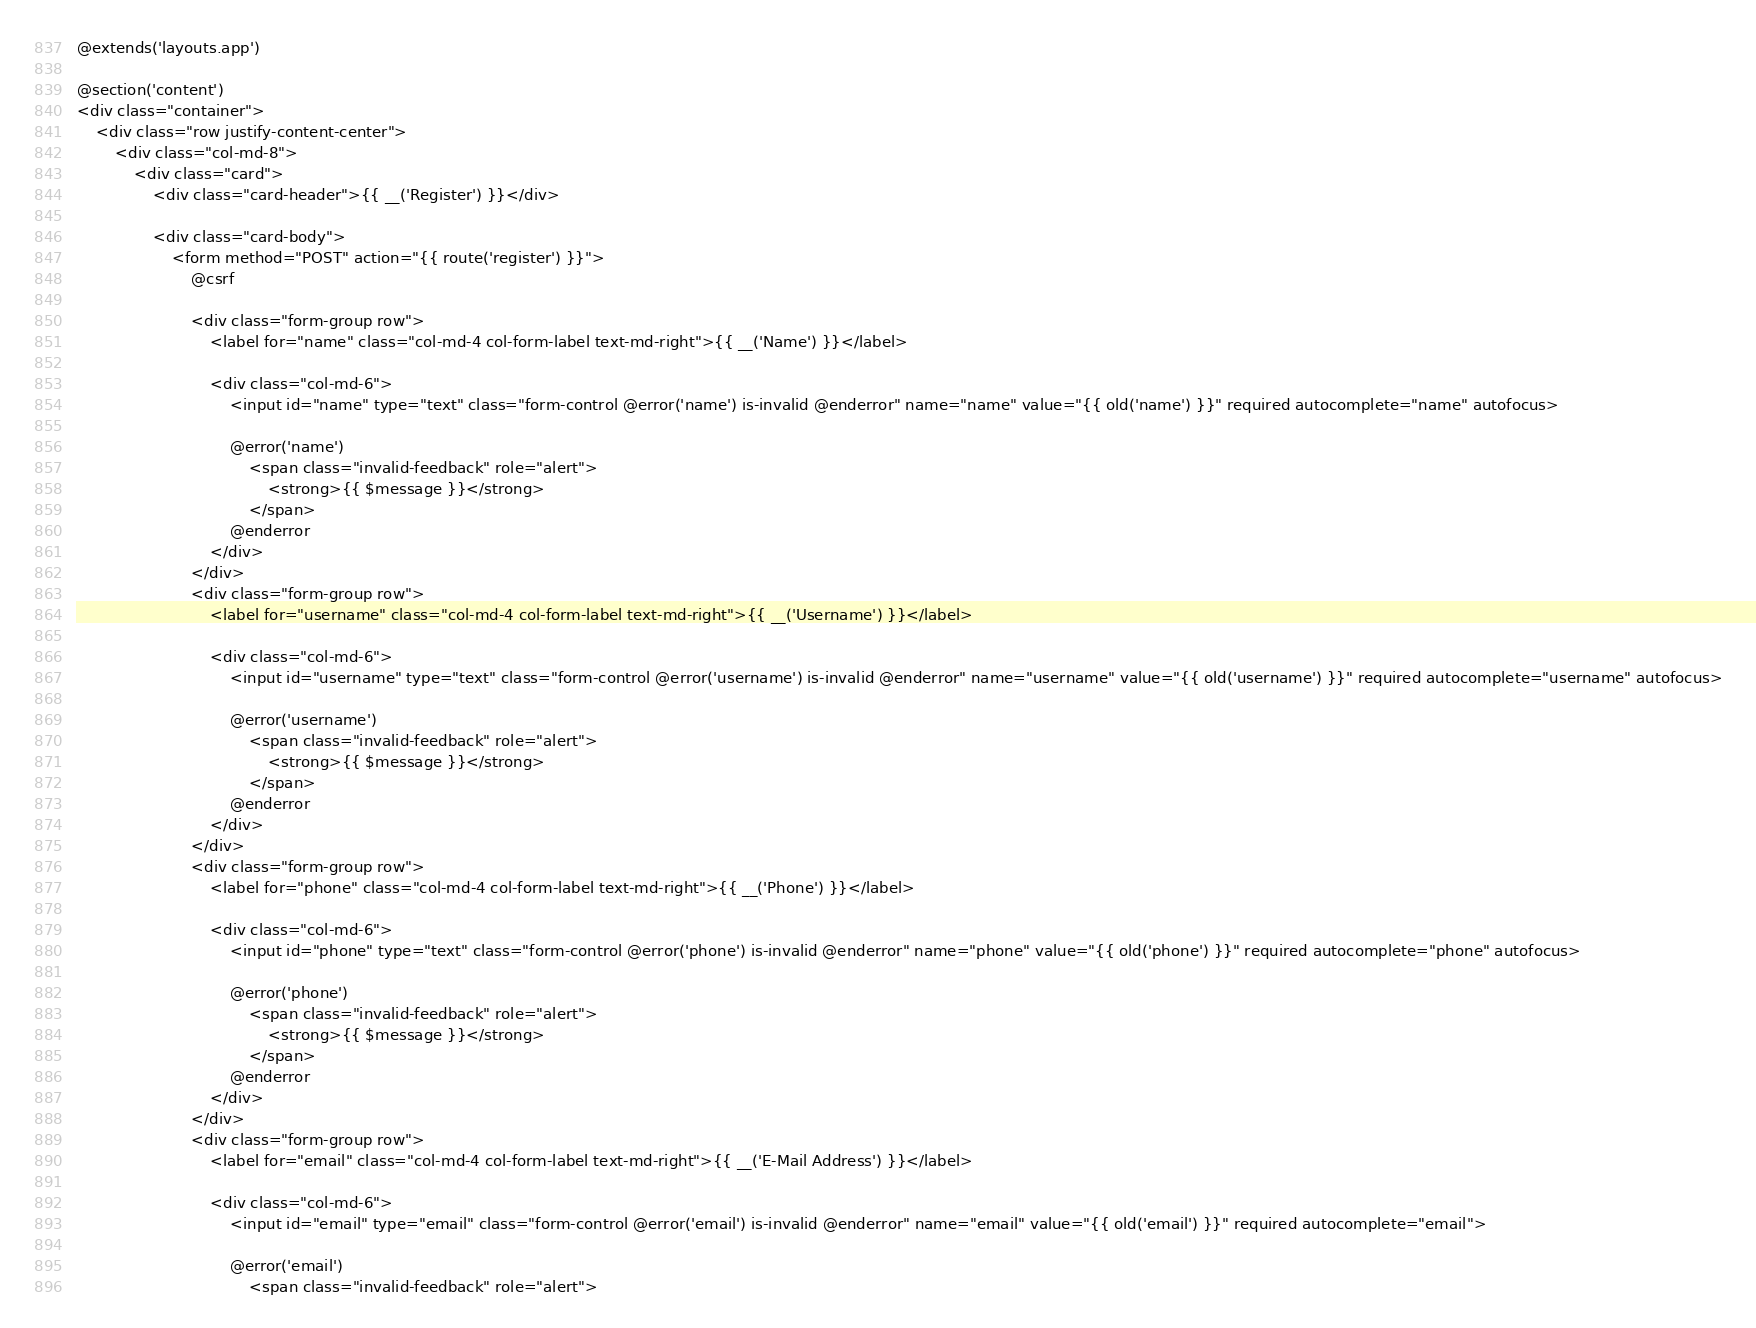Convert code to text. <code><loc_0><loc_0><loc_500><loc_500><_PHP_>@extends('layouts.app')

@section('content')
<div class="container">
    <div class="row justify-content-center">
        <div class="col-md-8">
            <div class="card">
                <div class="card-header">{{ __('Register') }}</div>

                <div class="card-body">
                    <form method="POST" action="{{ route('register') }}">
                        @csrf

                        <div class="form-group row">
                            <label for="name" class="col-md-4 col-form-label text-md-right">{{ __('Name') }}</label>

                            <div class="col-md-6">
                                <input id="name" type="text" class="form-control @error('name') is-invalid @enderror" name="name" value="{{ old('name') }}" required autocomplete="name" autofocus>

                                @error('name')
                                    <span class="invalid-feedback" role="alert">
                                        <strong>{{ $message }}</strong>
                                    </span>
                                @enderror
                            </div>
                        </div>
                        <div class="form-group row">
                            <label for="username" class="col-md-4 col-form-label text-md-right">{{ __('Username') }}</label>

                            <div class="col-md-6">
                                <input id="username" type="text" class="form-control @error('username') is-invalid @enderror" name="username" value="{{ old('username') }}" required autocomplete="username" autofocus>

                                @error('username')
                                    <span class="invalid-feedback" role="alert">
                                        <strong>{{ $message }}</strong>
                                    </span>
                                @enderror
                            </div>
                        </div>
                        <div class="form-group row">
                            <label for="phone" class="col-md-4 col-form-label text-md-right">{{ __('Phone') }}</label>

                            <div class="col-md-6">
                                <input id="phone" type="text" class="form-control @error('phone') is-invalid @enderror" name="phone" value="{{ old('phone') }}" required autocomplete="phone" autofocus>

                                @error('phone')
                                    <span class="invalid-feedback" role="alert">
                                        <strong>{{ $message }}</strong>
                                    </span>
                                @enderror
                            </div>
                        </div>
                        <div class="form-group row">
                            <label for="email" class="col-md-4 col-form-label text-md-right">{{ __('E-Mail Address') }}</label>

                            <div class="col-md-6">
                                <input id="email" type="email" class="form-control @error('email') is-invalid @enderror" name="email" value="{{ old('email') }}" required autocomplete="email">

                                @error('email')
                                    <span class="invalid-feedback" role="alert"></code> 